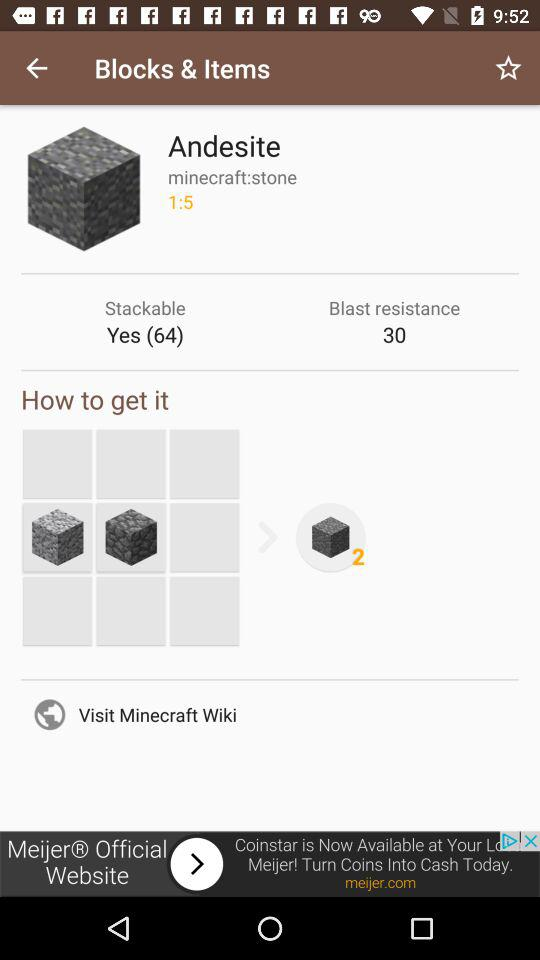How many stackable items are there? There are 64 stackable items. 